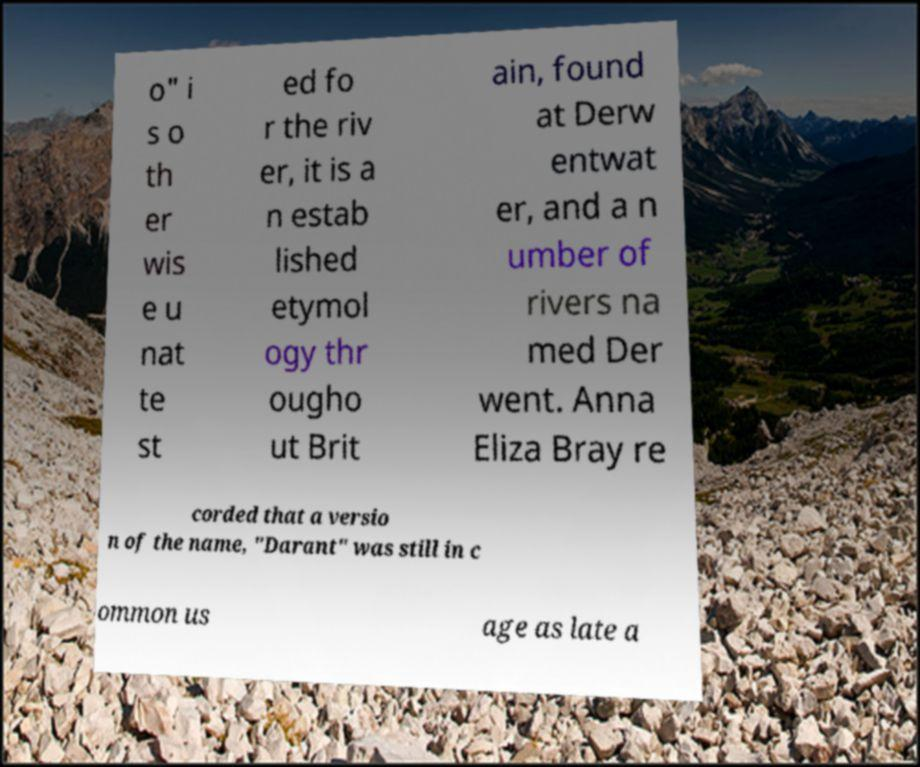Could you assist in decoding the text presented in this image and type it out clearly? o" i s o th er wis e u nat te st ed fo r the riv er, it is a n estab lished etymol ogy thr ougho ut Brit ain, found at Derw entwat er, and a n umber of rivers na med Der went. Anna Eliza Bray re corded that a versio n of the name, "Darant" was still in c ommon us age as late a 